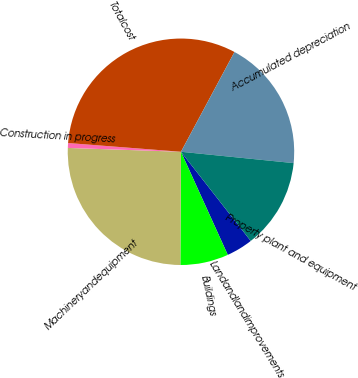Convert chart. <chart><loc_0><loc_0><loc_500><loc_500><pie_chart><fcel>Landandlandimprovements<fcel>Buildings<fcel>Machineryandequipment<fcel>Construction in progress<fcel>Totalcost<fcel>Accumulated depreciation<fcel>Property plant and equipment<nl><fcel>3.78%<fcel>6.87%<fcel>25.45%<fcel>0.69%<fcel>31.6%<fcel>18.76%<fcel>12.84%<nl></chart> 